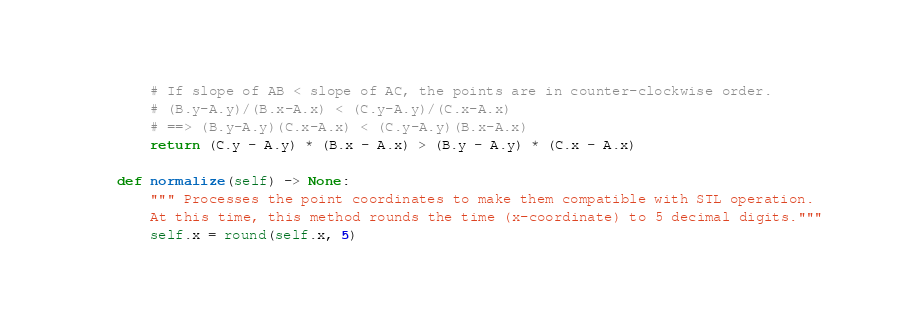Convert code to text. <code><loc_0><loc_0><loc_500><loc_500><_Python_>		# If slope of AB < slope of AC, the points are in counter-clockwise order.
		# (B.y-A.y)/(B.x-A.x) < (C.y-A.y)/(C.x-A.x)
		# ==> (B.y-A.y)(C.x-A.x) < (C.y-A.y)(B.x-A.x)
		return (C.y - A.y) * (B.x - A.x) > (B.y - A.y) * (C.x - A.x)

	def normalize(self) -> None:
		""" Processes the point coordinates to make them compatible with STL operation.
		At this time, this method rounds the time (x-coordinate) to 5 decimal digits."""
		self.x = round(self.x, 5)
</code> 